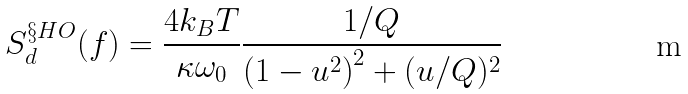Convert formula to latex. <formula><loc_0><loc_0><loc_500><loc_500>S _ { d } ^ { \S H O } ( f ) = \frac { 4 k _ { B } T } { \kappa \omega _ { 0 } } \frac { 1 / Q } { \left ( 1 - u ^ { 2 } \right ) ^ { 2 } + ( u / Q ) ^ { 2 } }</formula> 